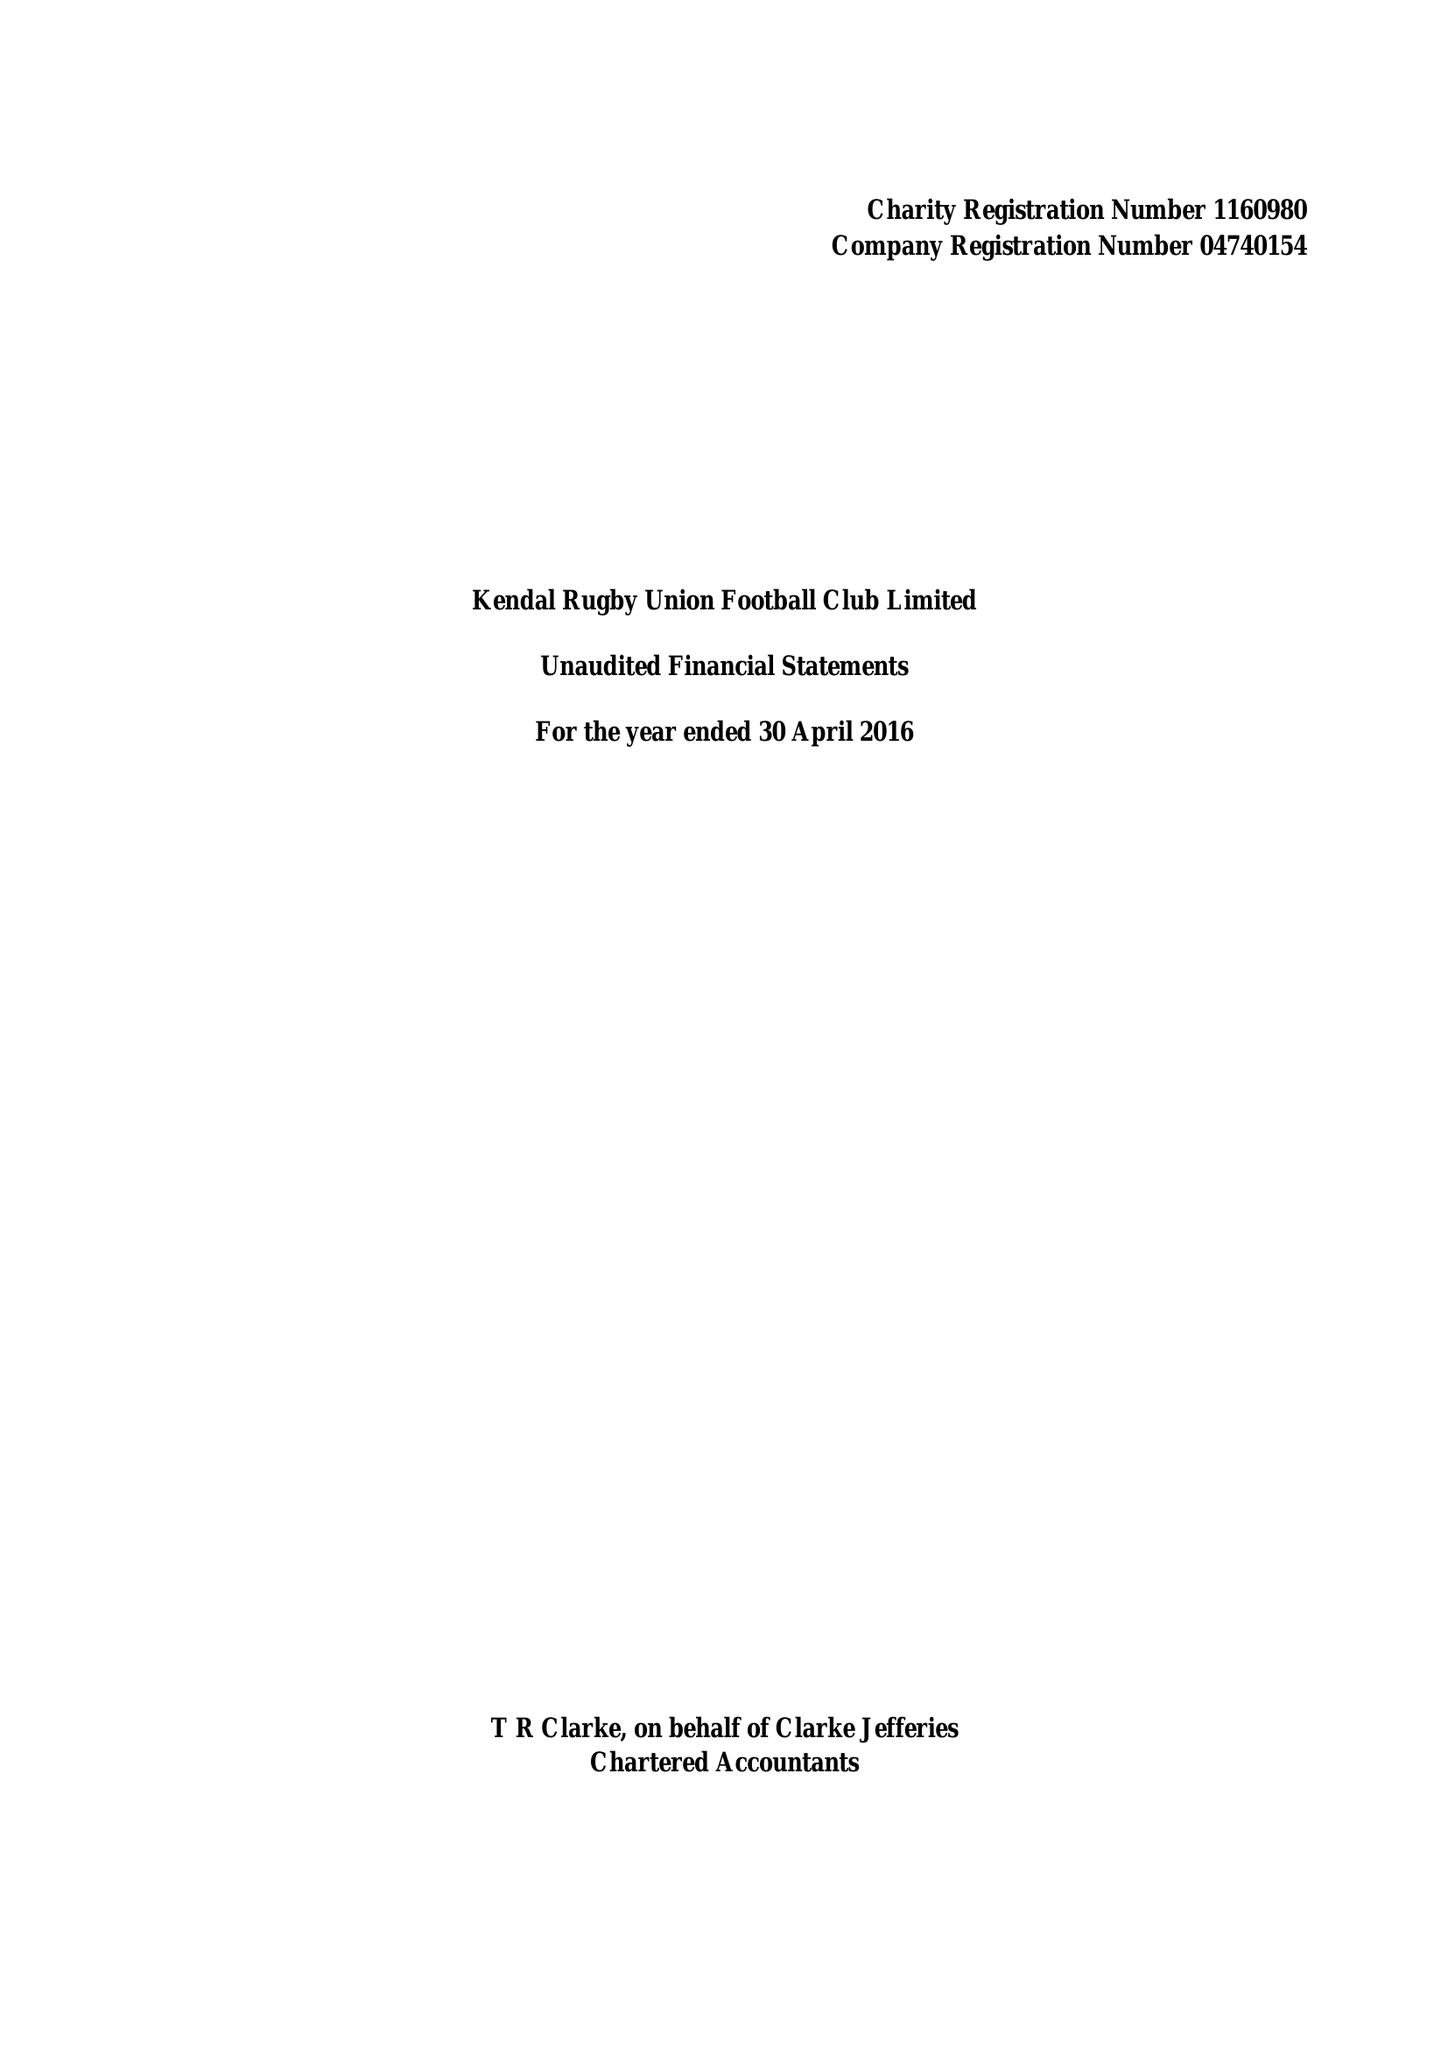What is the value for the address__postcode?
Answer the question using a single word or phrase. LA9 6NY 